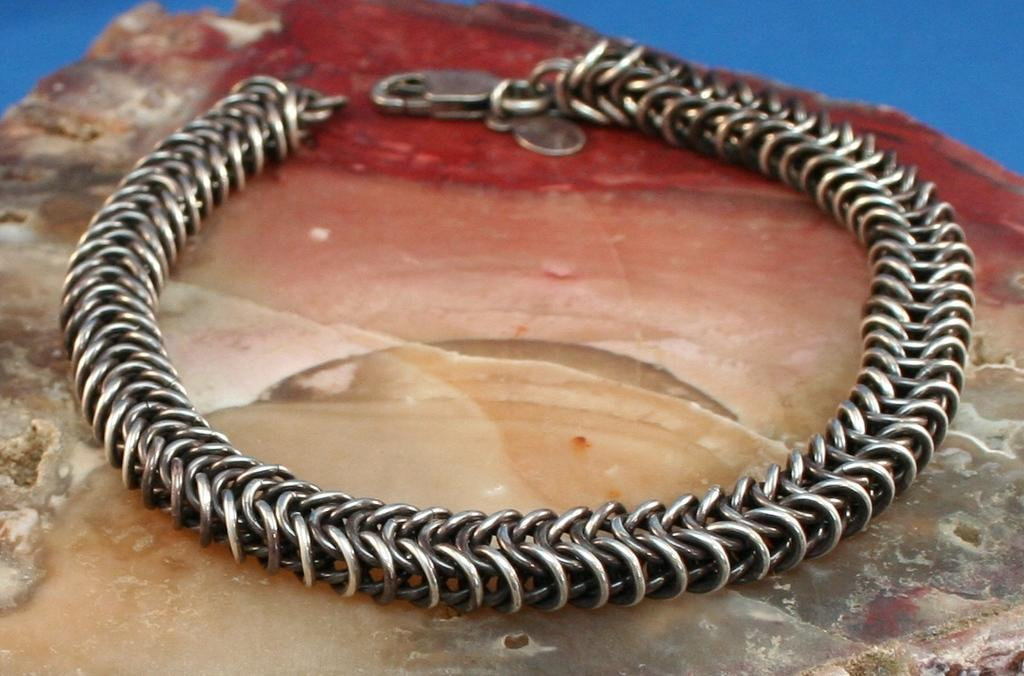What type of jewelry is featured in the picture? There is a bracelet in the picture. What is attached to the bottom of the bracelet? There appears to be a stone at the bottom of the bracelet. What color is the background behind the bracelet? There is a blue background behind the bracelet. What type of soup is being served in the library in the image? There is no library or soup present in the image; it features a bracelet with a stone and a blue background. 